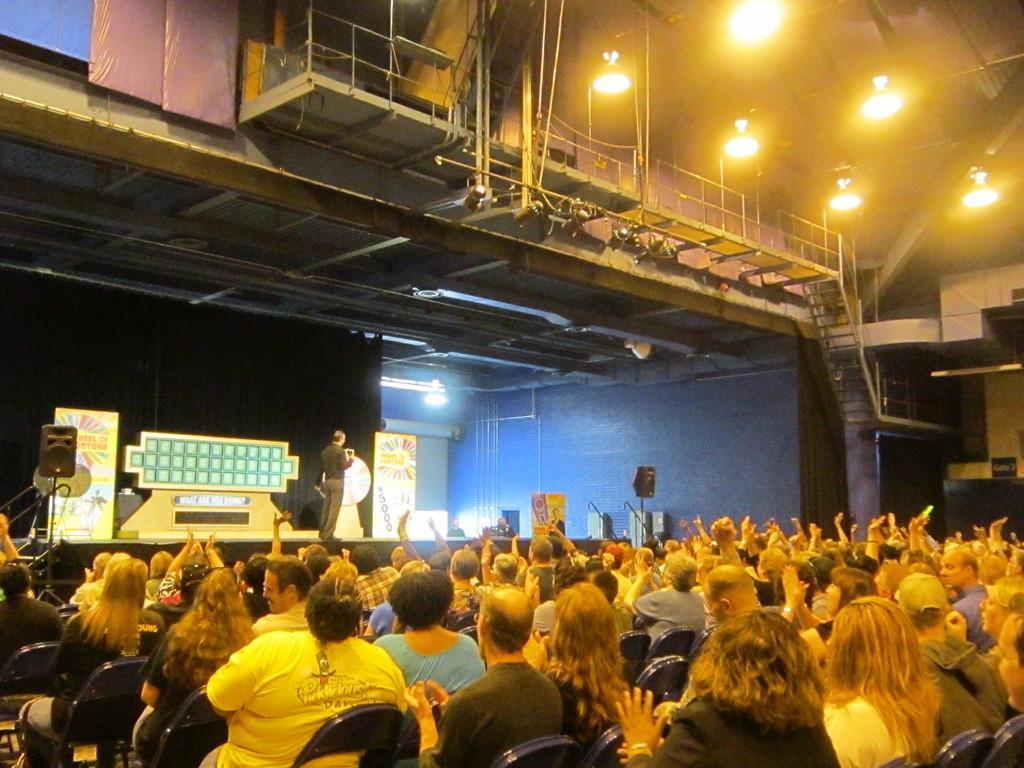How would you summarize this image in a sentence or two? This picture describes about group of people, few are seated on the chairs and a man is standing on the stage, in the background we can find few hoardings, speakers, metal rods and lights. 